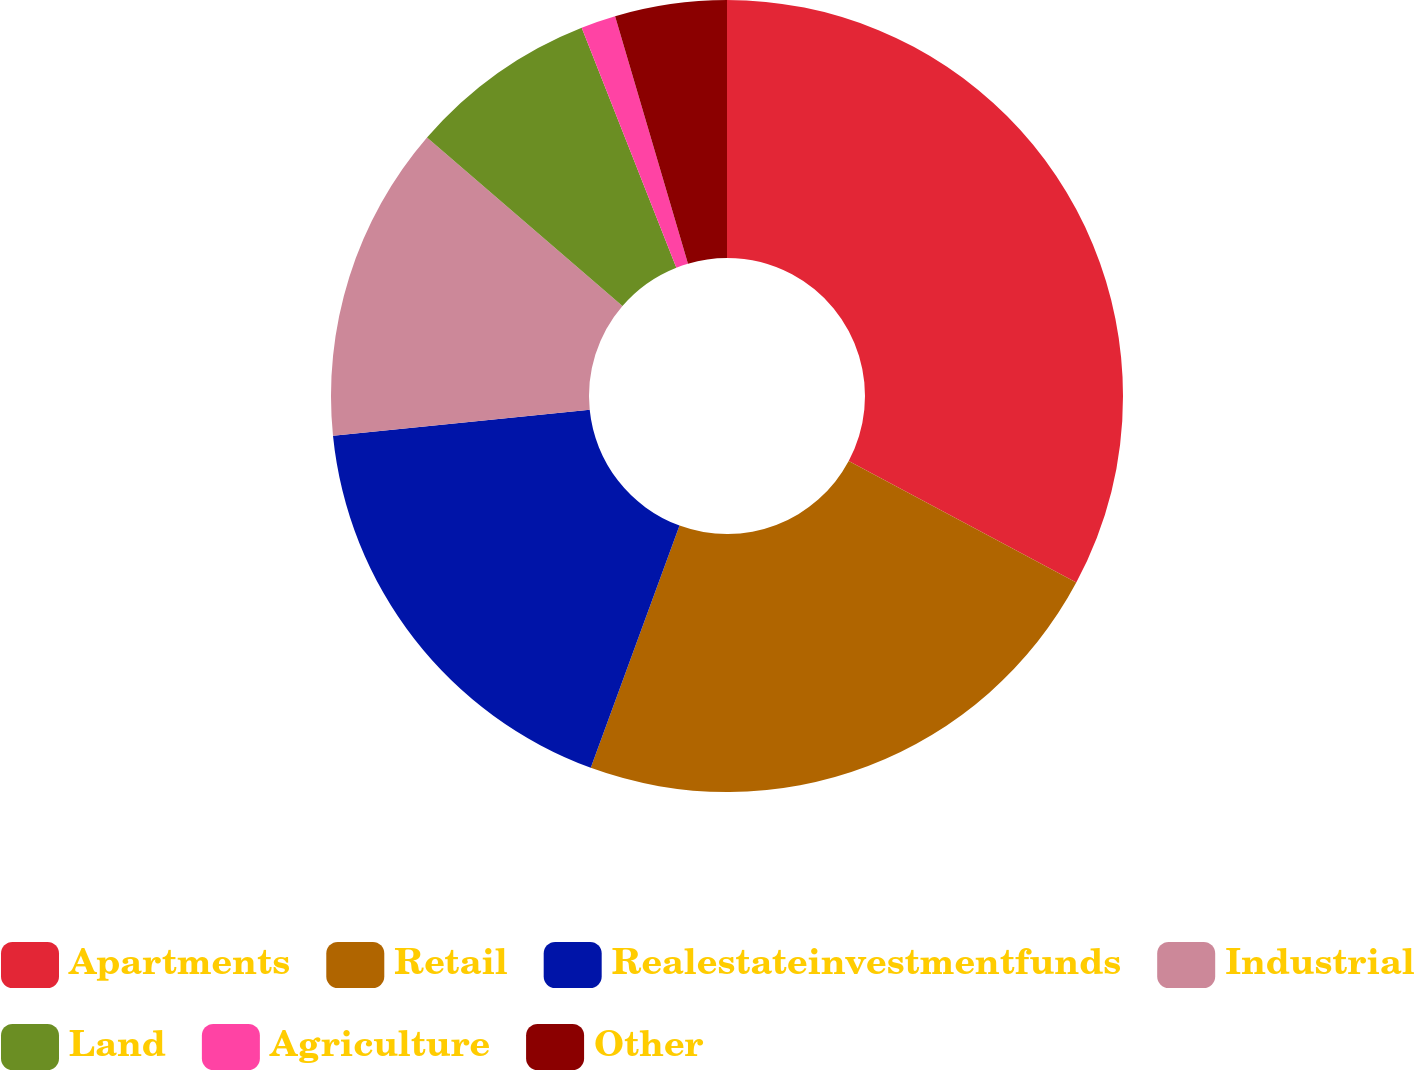<chart> <loc_0><loc_0><loc_500><loc_500><pie_chart><fcel>Apartments<fcel>Retail<fcel>Realestateinvestmentfunds<fcel>Industrial<fcel>Land<fcel>Agriculture<fcel>Other<nl><fcel>32.81%<fcel>22.78%<fcel>17.81%<fcel>12.92%<fcel>7.7%<fcel>1.42%<fcel>4.56%<nl></chart> 